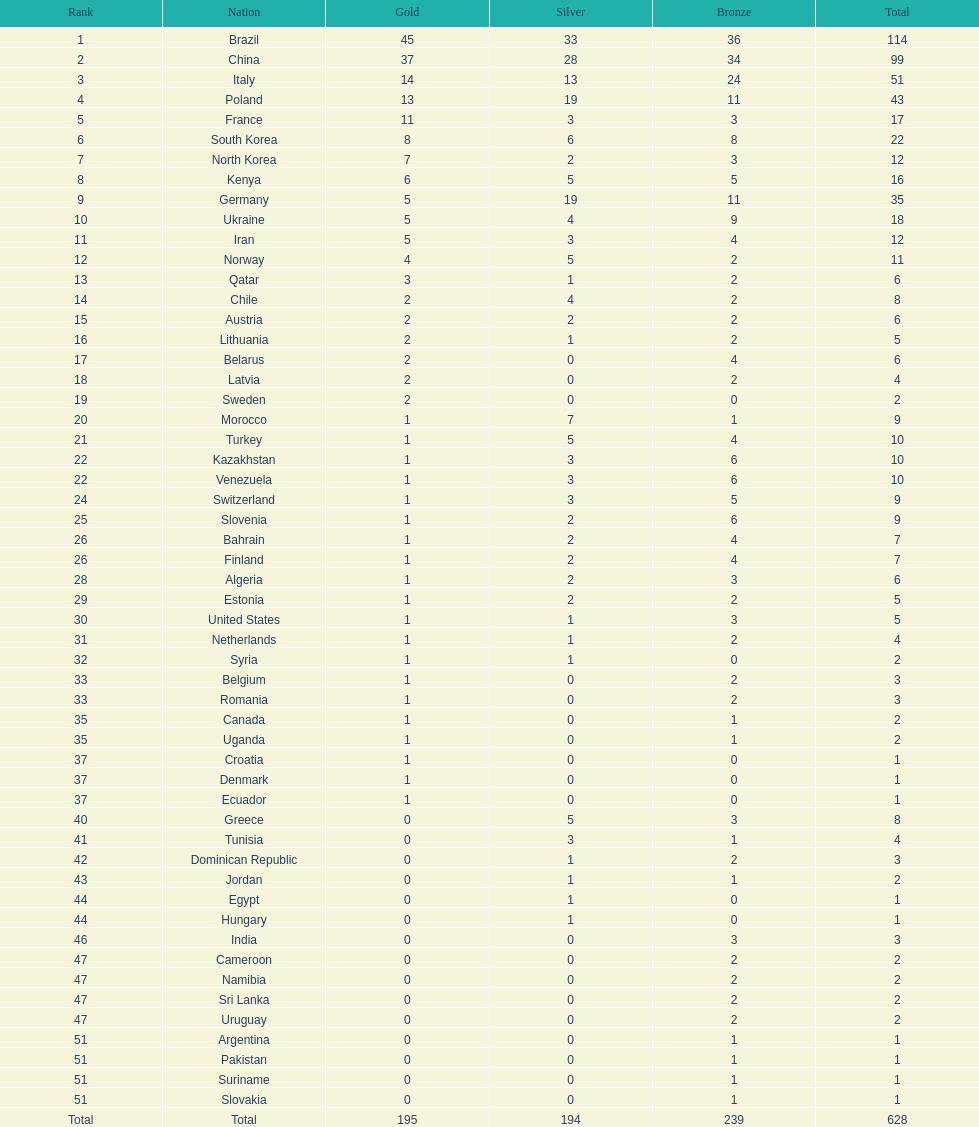What is the total number of medals between south korea, north korea, sweden, and brazil? 150. 